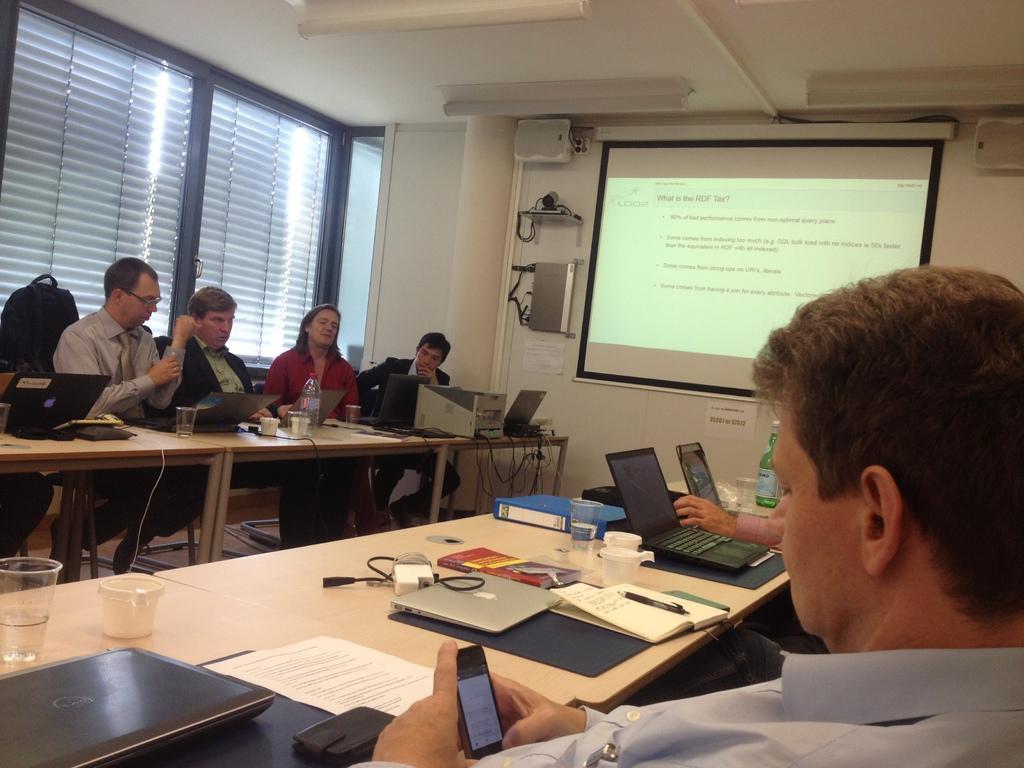In one or two sentences, can you explain what this image depicts? Here in this picture we can see a group of people sitting on chairs with table in front of them having laptops, files, papers, books on it and we can also see glasses, cup and bottles present and the person in the front is holding a mobile phone in his hand and in the middle of it , on the wall we can see a projector screen with something projected on it and behind them we can see window flaps covered. 